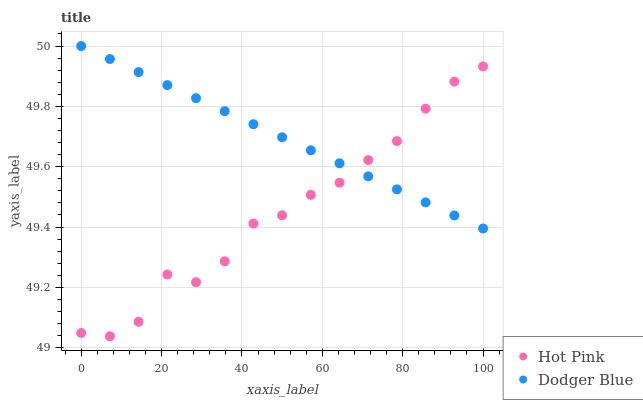Does Hot Pink have the minimum area under the curve?
Answer yes or no. Yes. Does Dodger Blue have the maximum area under the curve?
Answer yes or no. Yes. Does Dodger Blue have the minimum area under the curve?
Answer yes or no. No. Is Dodger Blue the smoothest?
Answer yes or no. Yes. Is Hot Pink the roughest?
Answer yes or no. Yes. Is Dodger Blue the roughest?
Answer yes or no. No. Does Hot Pink have the lowest value?
Answer yes or no. Yes. Does Dodger Blue have the lowest value?
Answer yes or no. No. Does Dodger Blue have the highest value?
Answer yes or no. Yes. Does Dodger Blue intersect Hot Pink?
Answer yes or no. Yes. Is Dodger Blue less than Hot Pink?
Answer yes or no. No. Is Dodger Blue greater than Hot Pink?
Answer yes or no. No. 